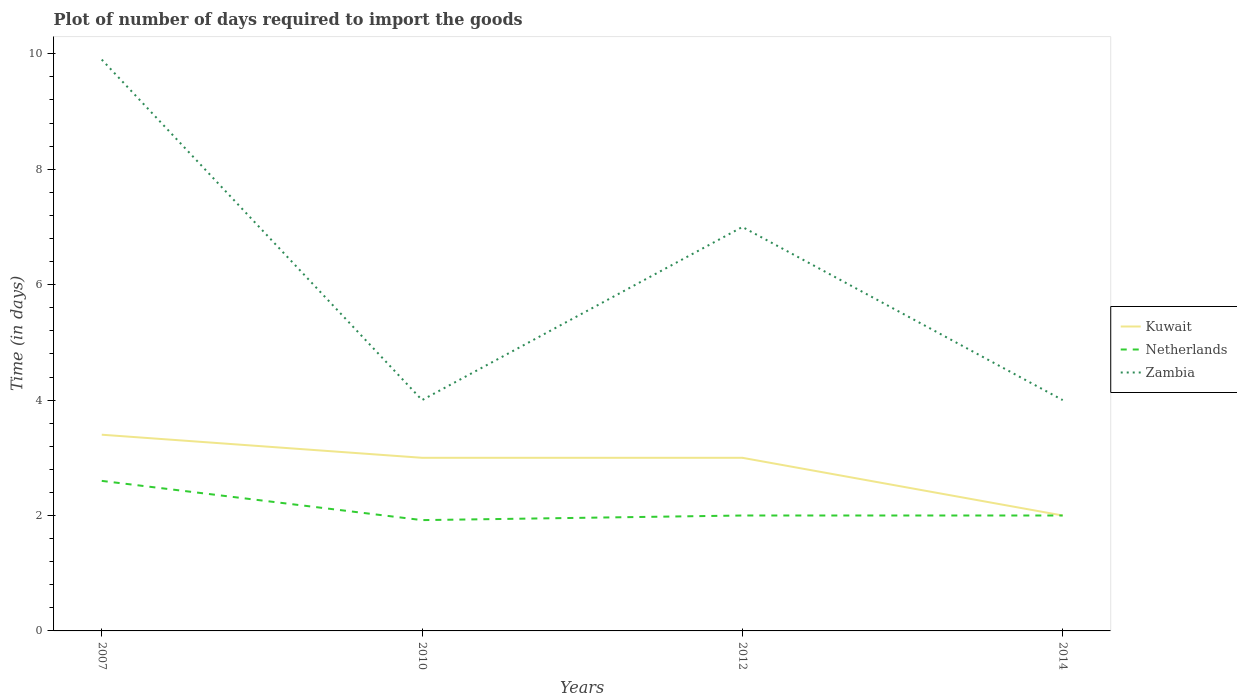Does the line corresponding to Kuwait intersect with the line corresponding to Zambia?
Your answer should be very brief. No. Across all years, what is the maximum time required to import goods in Netherlands?
Provide a succinct answer. 1.92. What is the total time required to import goods in Netherlands in the graph?
Keep it short and to the point. -0.08. What is the difference between the highest and the lowest time required to import goods in Zambia?
Your answer should be very brief. 2. Are the values on the major ticks of Y-axis written in scientific E-notation?
Provide a succinct answer. No. Does the graph contain any zero values?
Give a very brief answer. No. Does the graph contain grids?
Keep it short and to the point. No. How many legend labels are there?
Give a very brief answer. 3. What is the title of the graph?
Give a very brief answer. Plot of number of days required to import the goods. What is the label or title of the X-axis?
Give a very brief answer. Years. What is the label or title of the Y-axis?
Offer a terse response. Time (in days). What is the Time (in days) in Kuwait in 2007?
Provide a short and direct response. 3.4. What is the Time (in days) in Netherlands in 2007?
Your answer should be compact. 2.6. What is the Time (in days) in Netherlands in 2010?
Provide a short and direct response. 1.92. What is the Time (in days) of Kuwait in 2012?
Provide a short and direct response. 3. What is the Time (in days) of Kuwait in 2014?
Ensure brevity in your answer.  2. What is the Time (in days) of Netherlands in 2014?
Your answer should be very brief. 2. Across all years, what is the maximum Time (in days) of Kuwait?
Your answer should be compact. 3.4. Across all years, what is the maximum Time (in days) in Netherlands?
Give a very brief answer. 2.6. Across all years, what is the maximum Time (in days) of Zambia?
Offer a very short reply. 9.9. Across all years, what is the minimum Time (in days) of Kuwait?
Offer a very short reply. 2. Across all years, what is the minimum Time (in days) in Netherlands?
Provide a short and direct response. 1.92. What is the total Time (in days) of Kuwait in the graph?
Your answer should be compact. 11.4. What is the total Time (in days) of Netherlands in the graph?
Provide a succinct answer. 8.52. What is the total Time (in days) of Zambia in the graph?
Your response must be concise. 24.9. What is the difference between the Time (in days) of Kuwait in 2007 and that in 2010?
Your response must be concise. 0.4. What is the difference between the Time (in days) in Netherlands in 2007 and that in 2010?
Offer a very short reply. 0.68. What is the difference between the Time (in days) in Zambia in 2007 and that in 2010?
Give a very brief answer. 5.9. What is the difference between the Time (in days) of Kuwait in 2007 and that in 2012?
Provide a short and direct response. 0.4. What is the difference between the Time (in days) of Netherlands in 2007 and that in 2012?
Offer a very short reply. 0.6. What is the difference between the Time (in days) in Zambia in 2007 and that in 2012?
Give a very brief answer. 2.9. What is the difference between the Time (in days) of Netherlands in 2007 and that in 2014?
Make the answer very short. 0.6. What is the difference between the Time (in days) of Zambia in 2007 and that in 2014?
Make the answer very short. 5.9. What is the difference between the Time (in days) in Netherlands in 2010 and that in 2012?
Provide a succinct answer. -0.08. What is the difference between the Time (in days) of Kuwait in 2010 and that in 2014?
Your answer should be compact. 1. What is the difference between the Time (in days) of Netherlands in 2010 and that in 2014?
Give a very brief answer. -0.08. What is the difference between the Time (in days) of Kuwait in 2012 and that in 2014?
Offer a very short reply. 1. What is the difference between the Time (in days) of Zambia in 2012 and that in 2014?
Give a very brief answer. 3. What is the difference between the Time (in days) in Kuwait in 2007 and the Time (in days) in Netherlands in 2010?
Provide a short and direct response. 1.48. What is the difference between the Time (in days) of Kuwait in 2007 and the Time (in days) of Zambia in 2010?
Your answer should be compact. -0.6. What is the difference between the Time (in days) of Netherlands in 2007 and the Time (in days) of Zambia in 2010?
Make the answer very short. -1.4. What is the difference between the Time (in days) of Kuwait in 2007 and the Time (in days) of Netherlands in 2012?
Ensure brevity in your answer.  1.4. What is the difference between the Time (in days) of Netherlands in 2007 and the Time (in days) of Zambia in 2012?
Provide a succinct answer. -4.4. What is the difference between the Time (in days) in Kuwait in 2007 and the Time (in days) in Netherlands in 2014?
Provide a succinct answer. 1.4. What is the difference between the Time (in days) of Netherlands in 2007 and the Time (in days) of Zambia in 2014?
Keep it short and to the point. -1.4. What is the difference between the Time (in days) of Kuwait in 2010 and the Time (in days) of Netherlands in 2012?
Offer a terse response. 1. What is the difference between the Time (in days) of Kuwait in 2010 and the Time (in days) of Zambia in 2012?
Ensure brevity in your answer.  -4. What is the difference between the Time (in days) in Netherlands in 2010 and the Time (in days) in Zambia in 2012?
Make the answer very short. -5.08. What is the difference between the Time (in days) of Kuwait in 2010 and the Time (in days) of Netherlands in 2014?
Provide a short and direct response. 1. What is the difference between the Time (in days) of Netherlands in 2010 and the Time (in days) of Zambia in 2014?
Ensure brevity in your answer.  -2.08. What is the difference between the Time (in days) of Kuwait in 2012 and the Time (in days) of Netherlands in 2014?
Make the answer very short. 1. What is the difference between the Time (in days) in Netherlands in 2012 and the Time (in days) in Zambia in 2014?
Your answer should be compact. -2. What is the average Time (in days) in Kuwait per year?
Provide a succinct answer. 2.85. What is the average Time (in days) in Netherlands per year?
Offer a terse response. 2.13. What is the average Time (in days) in Zambia per year?
Make the answer very short. 6.22. In the year 2007, what is the difference between the Time (in days) in Kuwait and Time (in days) in Zambia?
Offer a terse response. -6.5. In the year 2007, what is the difference between the Time (in days) of Netherlands and Time (in days) of Zambia?
Provide a succinct answer. -7.3. In the year 2010, what is the difference between the Time (in days) of Kuwait and Time (in days) of Netherlands?
Offer a terse response. 1.08. In the year 2010, what is the difference between the Time (in days) in Kuwait and Time (in days) in Zambia?
Your answer should be very brief. -1. In the year 2010, what is the difference between the Time (in days) of Netherlands and Time (in days) of Zambia?
Offer a terse response. -2.08. In the year 2012, what is the difference between the Time (in days) in Kuwait and Time (in days) in Netherlands?
Your answer should be compact. 1. What is the ratio of the Time (in days) in Kuwait in 2007 to that in 2010?
Ensure brevity in your answer.  1.13. What is the ratio of the Time (in days) in Netherlands in 2007 to that in 2010?
Offer a very short reply. 1.35. What is the ratio of the Time (in days) in Zambia in 2007 to that in 2010?
Offer a terse response. 2.48. What is the ratio of the Time (in days) in Kuwait in 2007 to that in 2012?
Your answer should be compact. 1.13. What is the ratio of the Time (in days) of Zambia in 2007 to that in 2012?
Your response must be concise. 1.41. What is the ratio of the Time (in days) in Zambia in 2007 to that in 2014?
Your answer should be very brief. 2.48. What is the ratio of the Time (in days) in Kuwait in 2010 to that in 2012?
Provide a short and direct response. 1. What is the ratio of the Time (in days) of Zambia in 2010 to that in 2012?
Offer a terse response. 0.57. What is the ratio of the Time (in days) in Netherlands in 2010 to that in 2014?
Your response must be concise. 0.96. What is the ratio of the Time (in days) of Zambia in 2010 to that in 2014?
Make the answer very short. 1. What is the ratio of the Time (in days) in Kuwait in 2012 to that in 2014?
Ensure brevity in your answer.  1.5. What is the ratio of the Time (in days) in Zambia in 2012 to that in 2014?
Your response must be concise. 1.75. What is the difference between the highest and the second highest Time (in days) in Kuwait?
Give a very brief answer. 0.4. What is the difference between the highest and the second highest Time (in days) of Netherlands?
Offer a very short reply. 0.6. What is the difference between the highest and the lowest Time (in days) of Kuwait?
Give a very brief answer. 1.4. What is the difference between the highest and the lowest Time (in days) in Netherlands?
Your answer should be very brief. 0.68. 